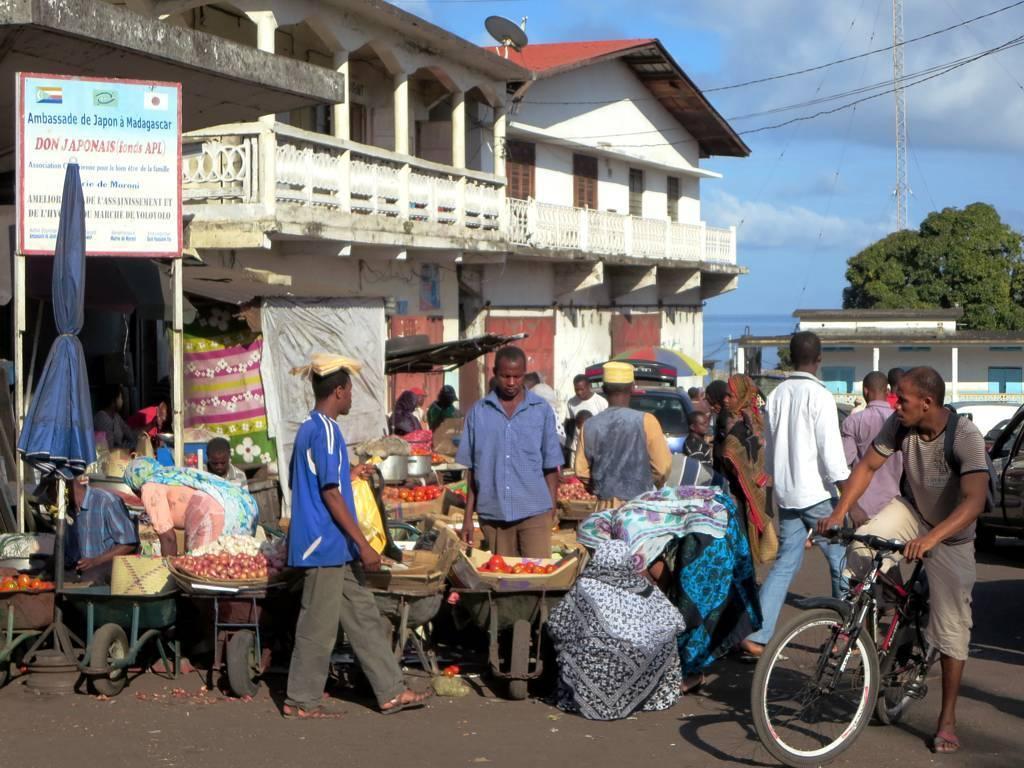In one or two sentences, can you explain what this image depicts? This picture shows a market. This is a vegetable market. There are some people who are purchasing and some are selling. In the background there is a house. There are some trees and sky with some clouds here. 